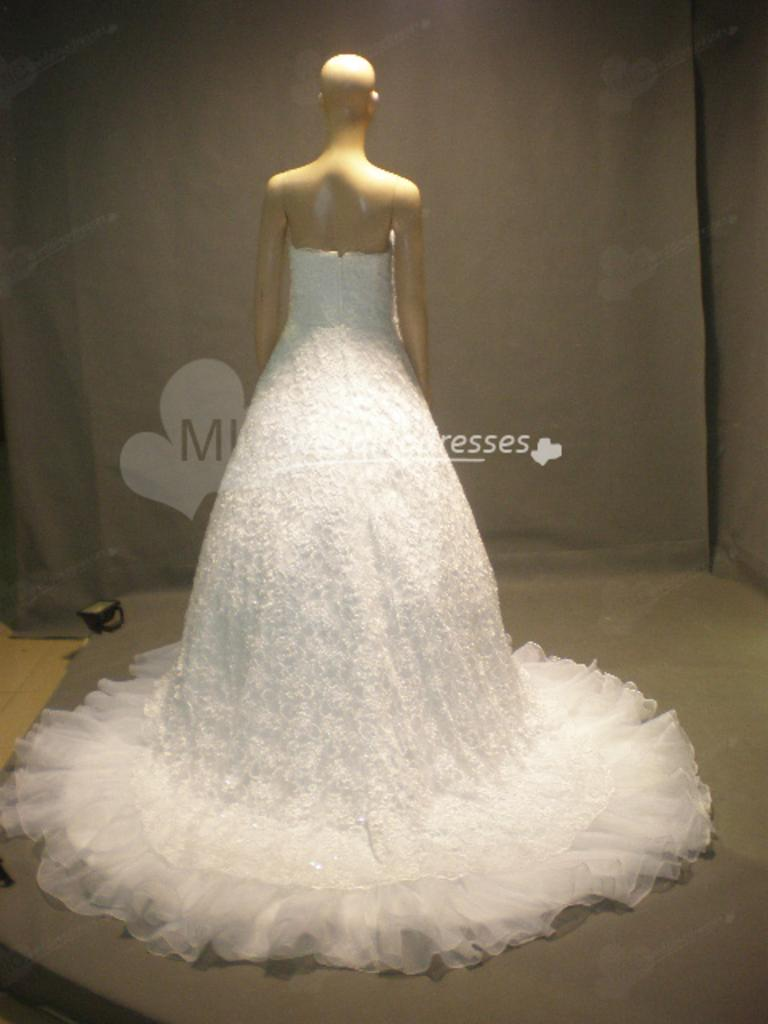What is the main subject in the image? There is a mannequin in the image. What is the mannequin wearing? The mannequin is wearing a white color dress. Can you describe the background of the image? The background of the image is ash color. What invention is the mannequin holding in the image? There is no invention present in the image; the mannequin is not holding anything. Can you see any pigs in the image? There are no pigs present in the image. 